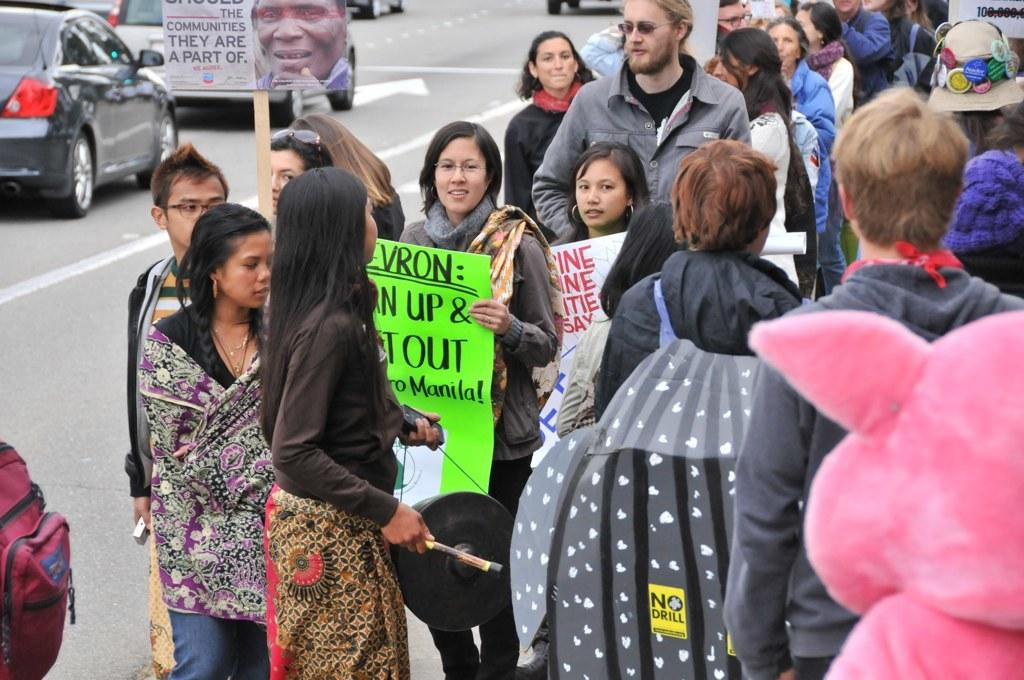Who or what can be seen in the image? There are people in the image. What are some of the people holding in the image? Some people are holding boards with text and other things. What else can be seen in the background of the image? There are vehicles visible on the road in the image. What type of canvas is being used to create the text on the boards? There is no canvas present in the image, as the text is on boards, not canvas. What color of ink is being used to write on the boards? There is no information about the color of ink used on the boards, as the focus is on the presence of boards with text and other things. 